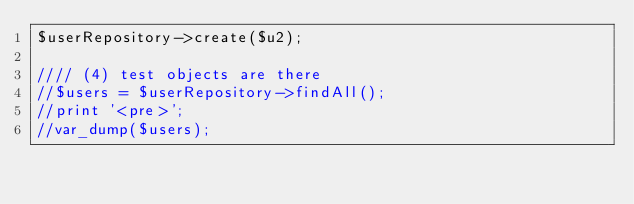<code> <loc_0><loc_0><loc_500><loc_500><_PHP_>$userRepository->create($u2);

//// (4) test objects are there
//$users = $userRepository->findAll();
//print '<pre>';
//var_dump($users);
</code> 